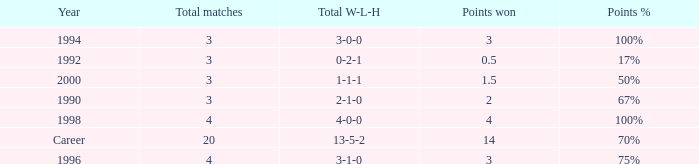Can you tell me the lowest Total natches that has the Points won of 3, and the Year of 1994? 3.0. 